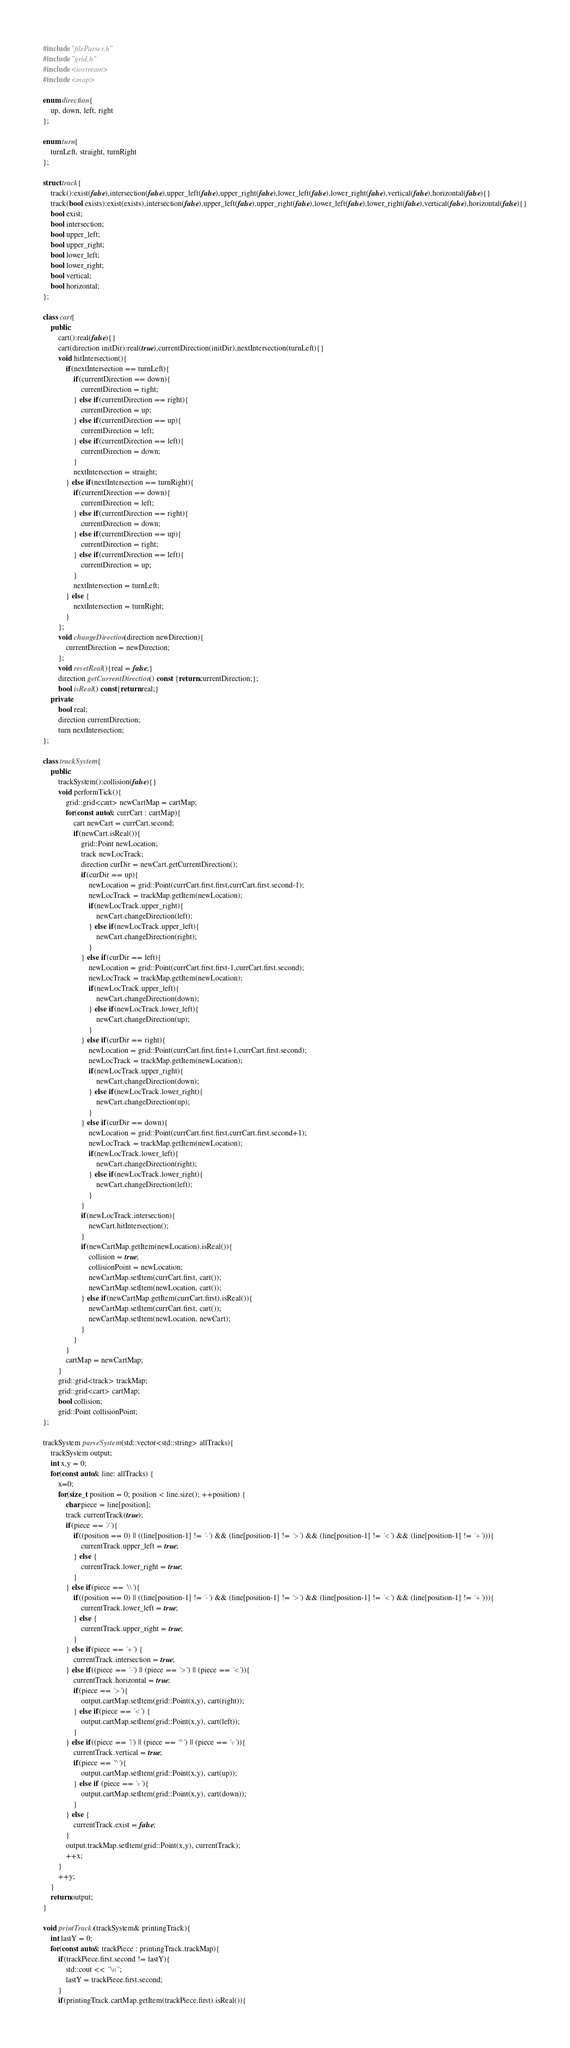Convert code to text. <code><loc_0><loc_0><loc_500><loc_500><_C++_>#include "fileParser.h"
#include "grid.h"
#include <iostream>
#include <map>

enum direction{
    up, down, left, right
};

enum turn{
    turnLeft, straight, turnRight
};

struct track{
    track():exist(false),intersection(false),upper_left(false),upper_right(false),lower_left(false),lower_right(false),vertical(false),horizontal(false){}
    track(bool exists):exist(exists),intersection(false),upper_left(false),upper_right(false),lower_left(false),lower_right(false),vertical(false),horizontal(false){}
    bool exist;
    bool intersection;
    bool upper_left;
    bool upper_right;
    bool lower_left;
    bool lower_right;
    bool vertical;
    bool horizontal;
};

class cart{
    public:
        cart():real(false){}
        cart(direction initDir):real(true),currentDirection(initDir),nextIntersection(turnLeft){}
        void hitIntersection(){
            if(nextIntersection == turnLeft){
                if(currentDirection == down){
                    currentDirection = right;
                } else if(currentDirection == right){
                    currentDirection = up;
                } else if(currentDirection == up){
                    currentDirection = left;
                } else if(currentDirection == left){
                    currentDirection = down;
                }
                nextIntersection = straight;
            } else if(nextIntersection == turnRight){
                if(currentDirection == down){
                    currentDirection = left;
                } else if(currentDirection == right){
                    currentDirection = down;
                } else if(currentDirection == up){
                    currentDirection = right;
                } else if(currentDirection == left){
                    currentDirection = up;
                }
                nextIntersection = turnLeft;
            } else {
                nextIntersection = turnRight;
            }
        };
        void changeDirection(direction newDirection){
            currentDirection = newDirection;
        };
        void resetReal(){real = false;}
        direction getCurrentDirection() const {return currentDirection;};
        bool isReal() const{return real;}
    private:
        bool real;
        direction currentDirection;
        turn nextIntersection;
};

class trackSystem{
    public:
        trackSystem():collision(false){}
        void performTick(){
            grid::grid<cart> newCartMap = cartMap;
            for(const auto& currCart : cartMap){
                cart newCart = currCart.second;
                if(newCart.isReal()){
                    grid::Point newLocation;
                    track newLocTrack;
                    direction curDir = newCart.getCurrentDirection();
                    if(curDir == up){
                        newLocation = grid::Point(currCart.first.first,currCart.first.second-1);
                        newLocTrack = trackMap.getItem(newLocation);
                        if(newLocTrack.upper_right){
                            newCart.changeDirection(left);
                        } else if(newLocTrack.upper_left){
                            newCart.changeDirection(right);
                        }
                    } else if(curDir == left){
                        newLocation = grid::Point(currCart.first.first-1,currCart.first.second);
                        newLocTrack = trackMap.getItem(newLocation);
                        if(newLocTrack.upper_left){
                            newCart.changeDirection(down);
                        } else if(newLocTrack.lower_left){
                            newCart.changeDirection(up);
                        }
                    } else if(curDir == right){
                        newLocation = grid::Point(currCart.first.first+1,currCart.first.second);
                        newLocTrack = trackMap.getItem(newLocation);
                        if(newLocTrack.upper_right){
                            newCart.changeDirection(down);
                        } else if(newLocTrack.lower_right){
                            newCart.changeDirection(up);
                        }
                    } else if(curDir == down){
                        newLocation = grid::Point(currCart.first.first,currCart.first.second+1);
                        newLocTrack = trackMap.getItem(newLocation);
                        if(newLocTrack.lower_left){
                            newCart.changeDirection(right);
                        } else if(newLocTrack.lower_right){
                            newCart.changeDirection(left);
                        }
                    }
                    if(newLocTrack.intersection){
                        newCart.hitIntersection();
                    }
                    if(newCartMap.getItem(newLocation).isReal()){
                        collision = true;
                        collisionPoint = newLocation;
                        newCartMap.setItem(currCart.first, cart());
                        newCartMap.setItem(newLocation, cart());
                    } else if(newCartMap.getItem(currCart.first).isReal()){
                        newCartMap.setItem(currCart.first, cart());
                        newCartMap.setItem(newLocation, newCart);
                    }
                }
            }
            cartMap = newCartMap;
        }
        grid::grid<track> trackMap;
        grid::grid<cart> cartMap;
        bool collision;
        grid::Point collisionPoint;
};

trackSystem parseSystem(std::vector<std::string> allTracks){
    trackSystem output;
    int x,y = 0;
    for(const auto& line: allTracks) {
        x=0;
        for(size_t position = 0; position < line.size(); ++position) {
            char piece = line[position];
            track currentTrack(true);
            if(piece == '/'){
                if((position == 0) || ((line[position-1] != '-') && (line[position-1] != '>') && (line[position-1] != '<') && (line[position-1] != '+'))){
                    currentTrack.upper_left = true;
                } else {
                    currentTrack.lower_right = true;
                }
            } else if(piece == '\\'){
                if((position == 0) || ((line[position-1] != '-') && (line[position-1] != '>') && (line[position-1] != '<') && (line[position-1] != '+'))){
                    currentTrack.lower_left = true;
                } else {
                    currentTrack.upper_right = true;
                }
            } else if(piece == '+') {
                currentTrack.intersection = true;
            } else if((piece == '-') || (piece == '>') || (piece == '<')){
                currentTrack.horizontal = true;
                if(piece == '>'){
                    output.cartMap.setItem(grid::Point(x,y), cart(right));
                } else if(piece == '<') {
                    output.cartMap.setItem(grid::Point(x,y), cart(left));
                }
            } else if((piece == '|') || (piece == '^') || (piece == 'v')){
                currentTrack.vertical = true;
                if(piece == '^'){
                    output.cartMap.setItem(grid::Point(x,y), cart(up));
                } else if (piece == 'v'){
                    output.cartMap.setItem(grid::Point(x,y), cart(down));
                }
            } else {
                currentTrack.exist = false;
            }
            output.trackMap.setItem(grid::Point(x,y), currentTrack);
            ++x;
        }
        ++y;
    }
    return output;
}

void printTracks(trackSystem& printingTrack){
    int lastY = 0;
    for(const auto& trackPiece : printingTrack.trackMap){
        if(trackPiece.first.second != lastY){
            std::cout << "\n";
            lastY = trackPiece.first.second;
        }
        if(printingTrack.cartMap.getItem(trackPiece.first).isReal()){</code> 